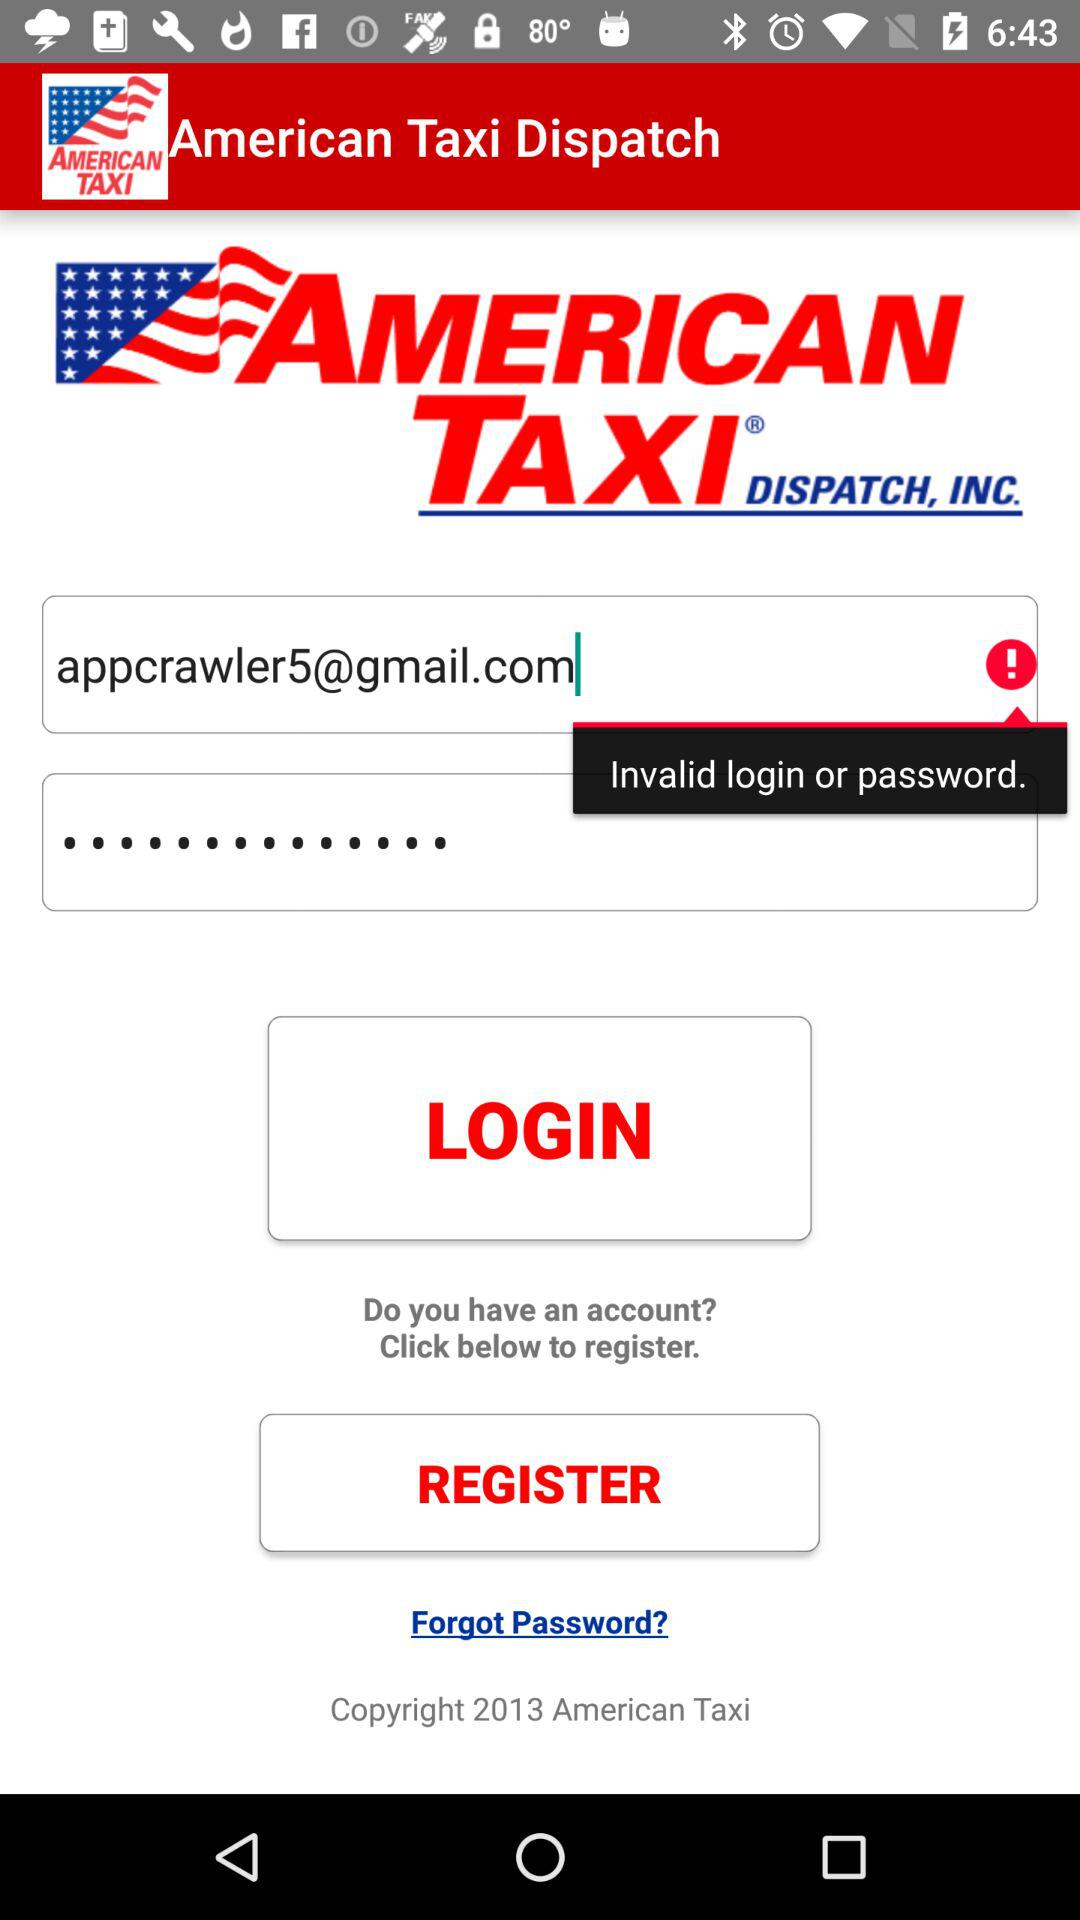What is the copyright year? The copyright year is 2013. 